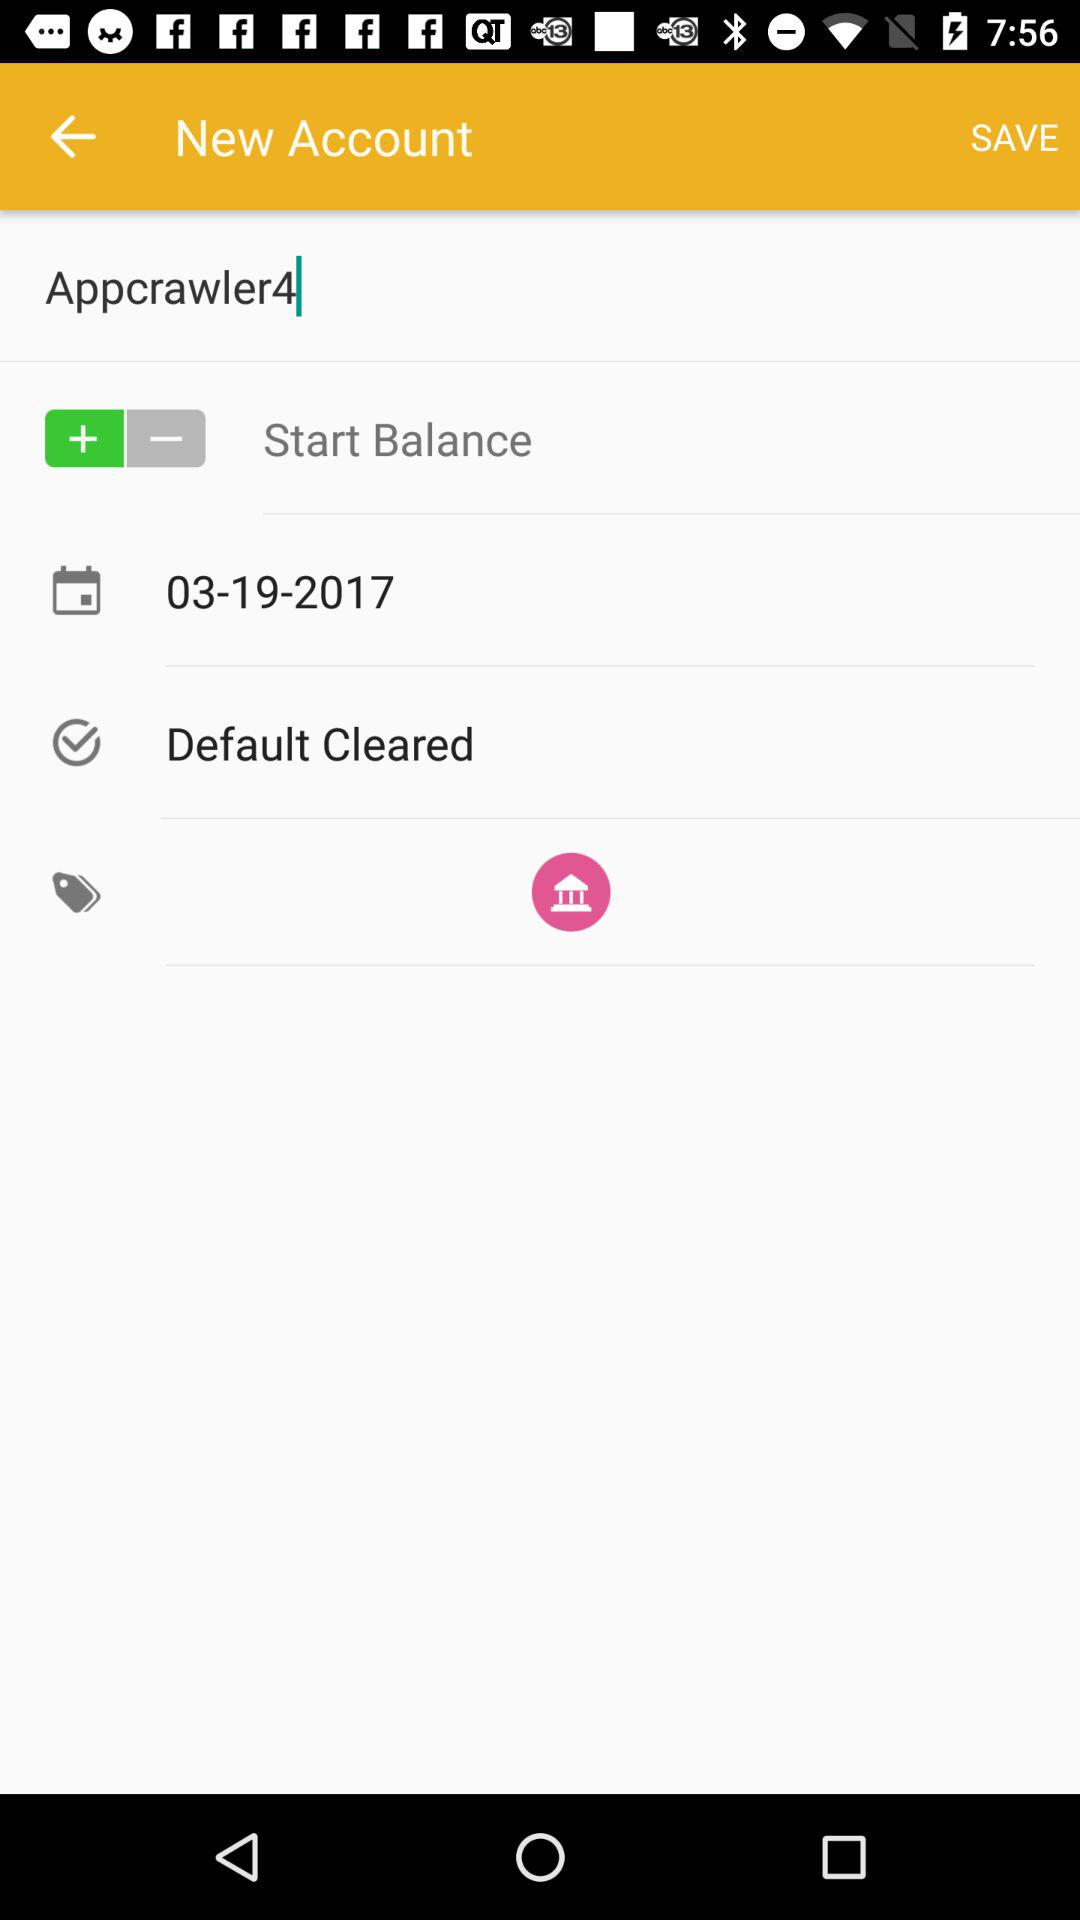What is the date? The date is March 19, 2017. 